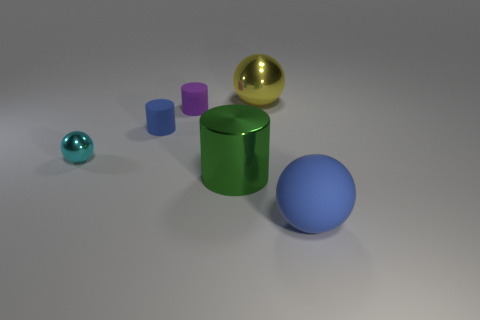Add 1 big gray rubber blocks. How many objects exist? 7 Subtract all tiny cyan metal spheres. How many spheres are left? 2 Subtract 0 red cubes. How many objects are left? 6 Subtract 2 spheres. How many spheres are left? 1 Subtract all cyan balls. Subtract all green cubes. How many balls are left? 2 Subtract all yellow balls. How many green cylinders are left? 1 Subtract all big green cylinders. Subtract all large blue spheres. How many objects are left? 4 Add 4 cylinders. How many cylinders are left? 7 Add 1 blue matte objects. How many blue matte objects exist? 3 Subtract all blue balls. How many balls are left? 2 